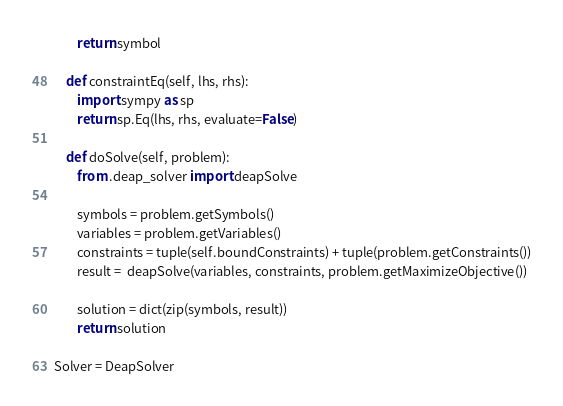<code> <loc_0><loc_0><loc_500><loc_500><_Python_>		return symbol

	def constraintEq(self, lhs, rhs):
		import sympy as sp
		return sp.Eq(lhs, rhs, evaluate=False)

	def doSolve(self, problem):
		from .deap_solver import deapSolve

		symbols = problem.getSymbols()
		variables = problem.getVariables()
		constraints = tuple(self.boundConstraints) + tuple(problem.getConstraints())
		result =  deapSolve(variables, constraints, problem.getMaximizeObjective())

		solution = dict(zip(symbols, result))
		return solution

Solver = DeapSolver
</code> 